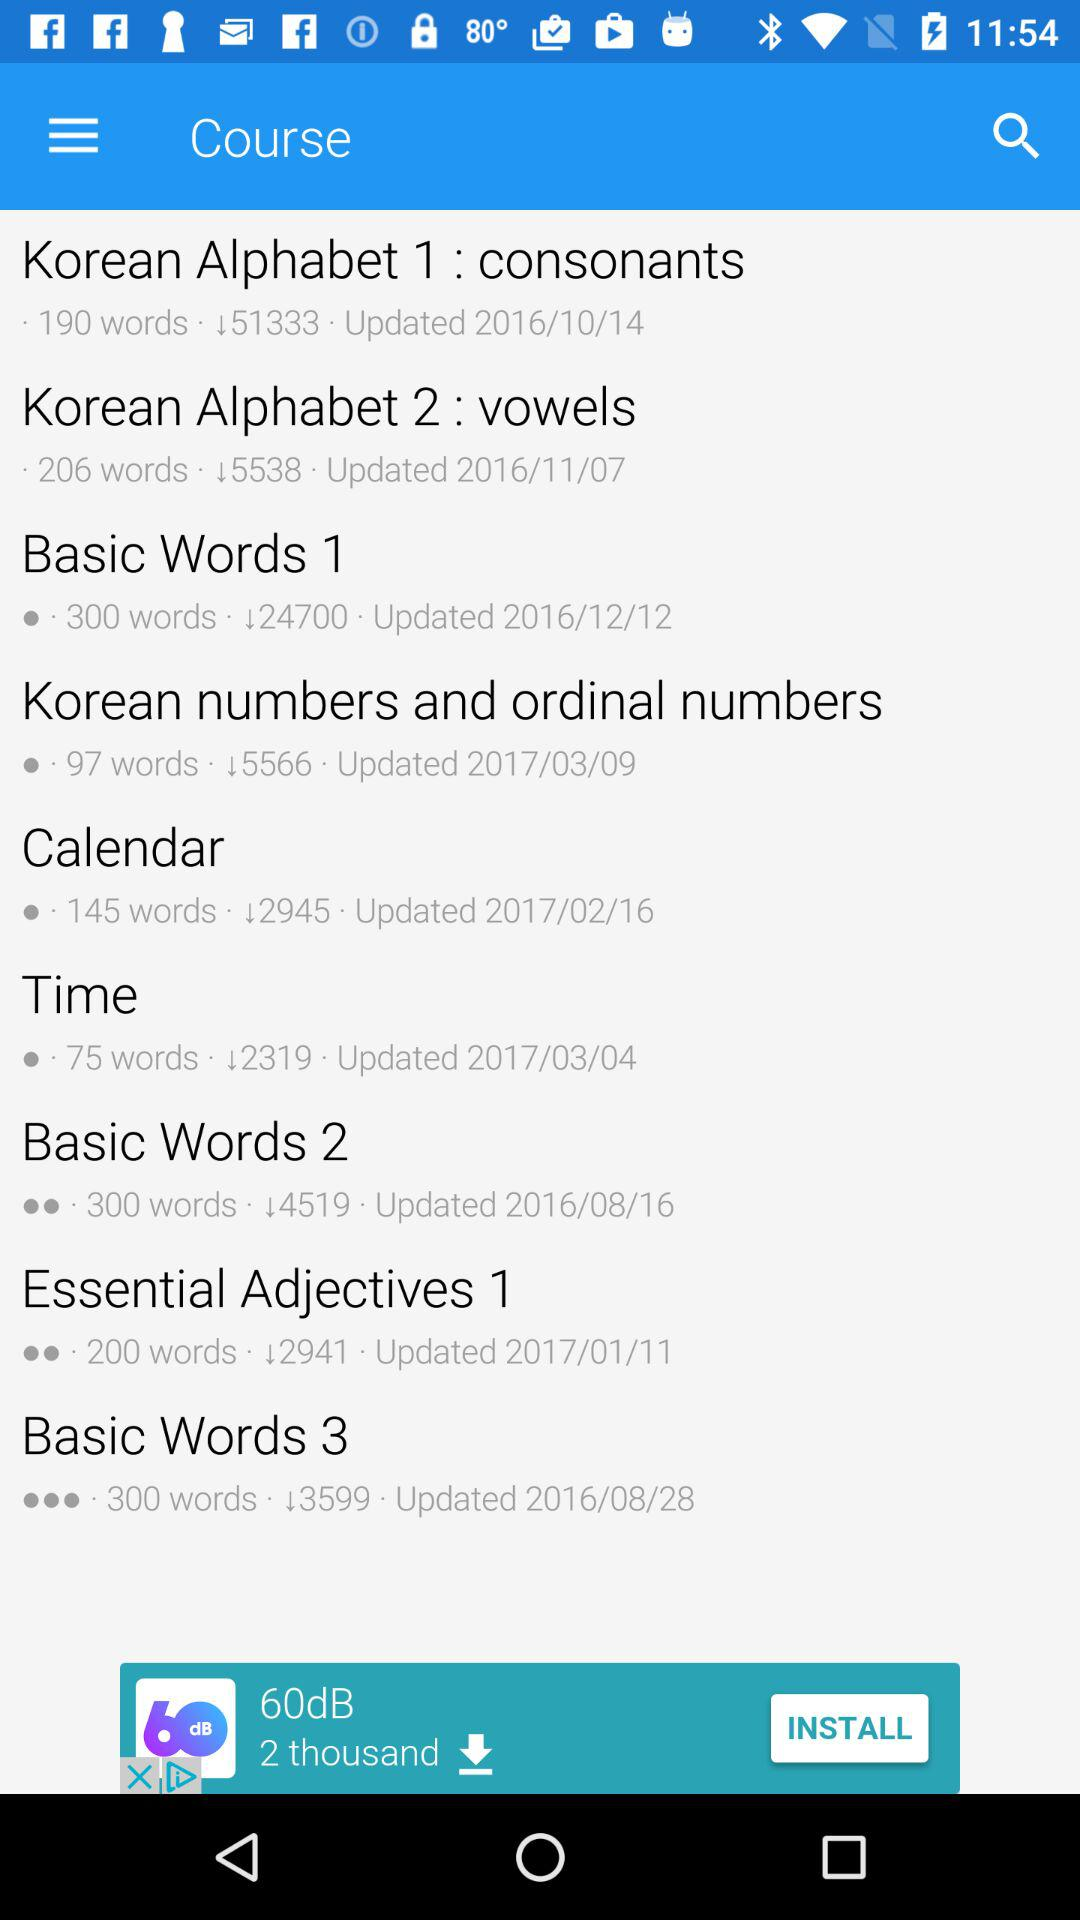What is the total number of words in the course "Calendar"? The total number of words in the course "Calendar" is 145. 